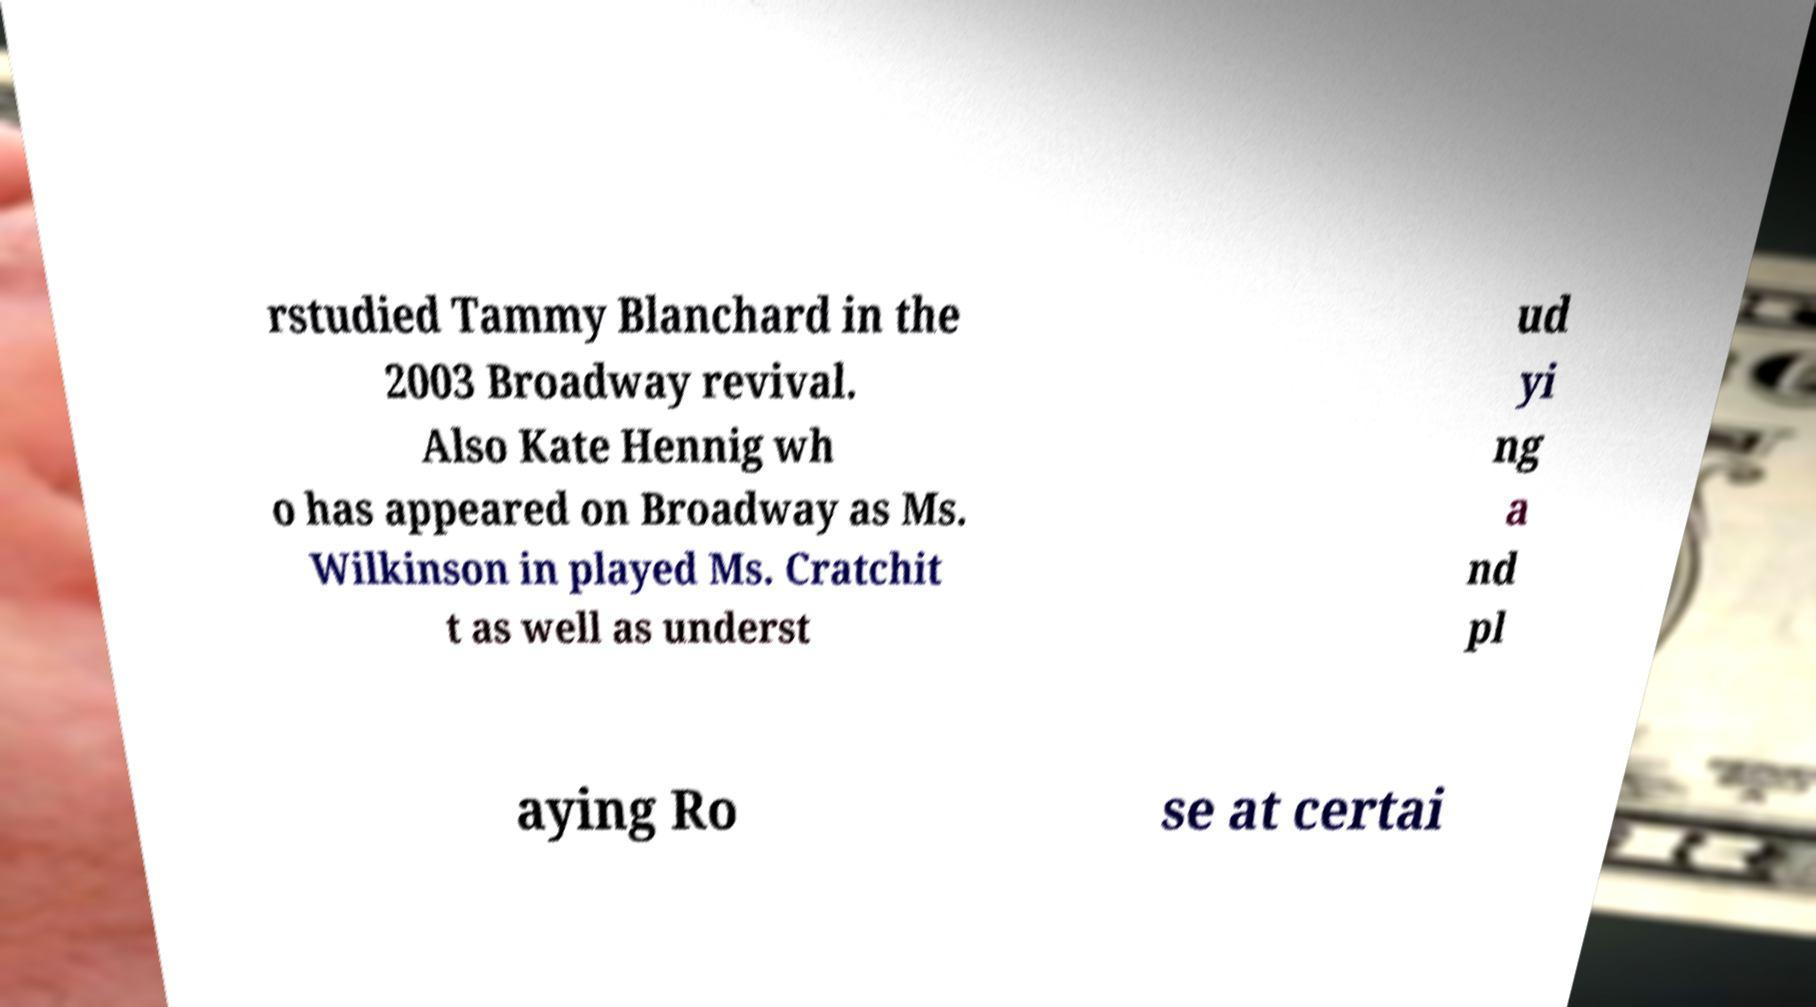For documentation purposes, I need the text within this image transcribed. Could you provide that? rstudied Tammy Blanchard in the 2003 Broadway revival. Also Kate Hennig wh o has appeared on Broadway as Ms. Wilkinson in played Ms. Cratchit t as well as underst ud yi ng a nd pl aying Ro se at certai 